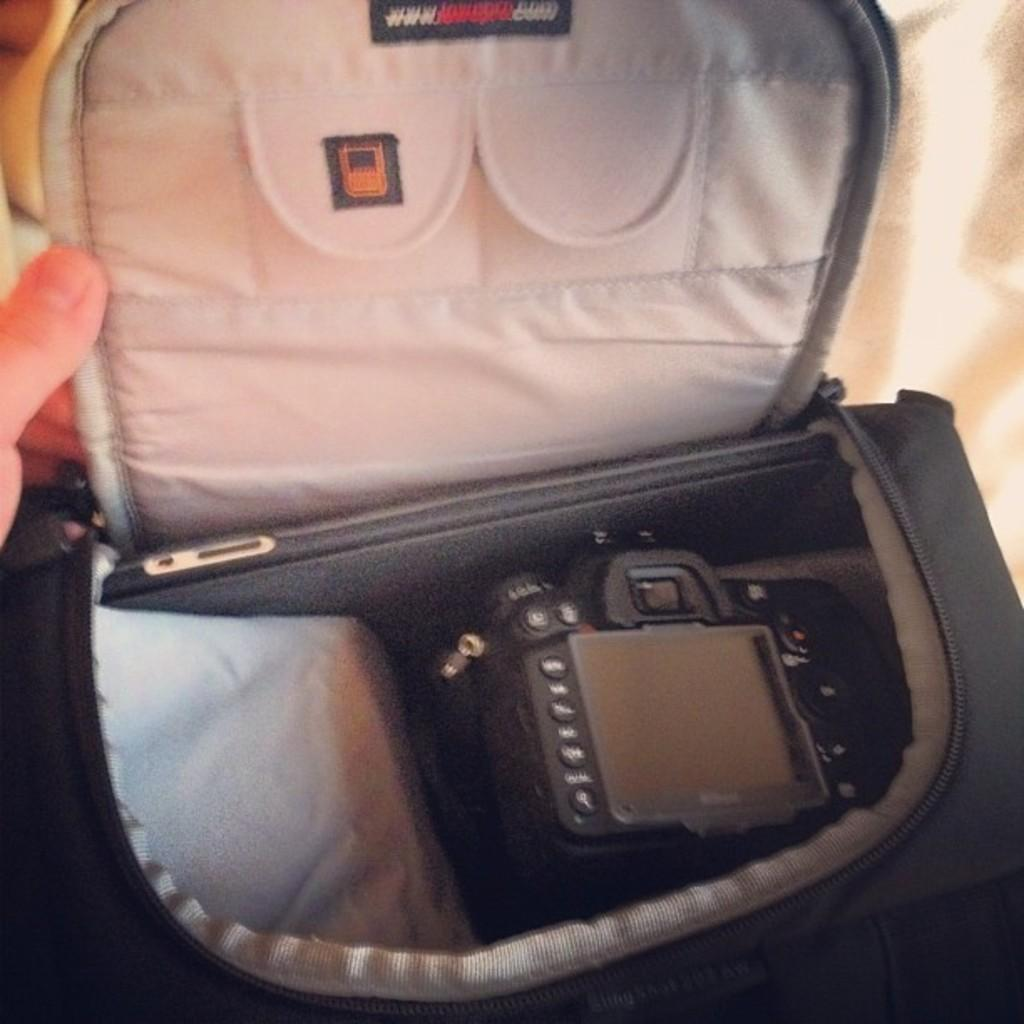What is the color of the bag in the image? The bag in the image is black. What is inside the black color bag? There is a camera in the black color bag. What type of organization is associated with the snake in the image? There is no snake present in the image, so it is not possible to associate it with any organization. 